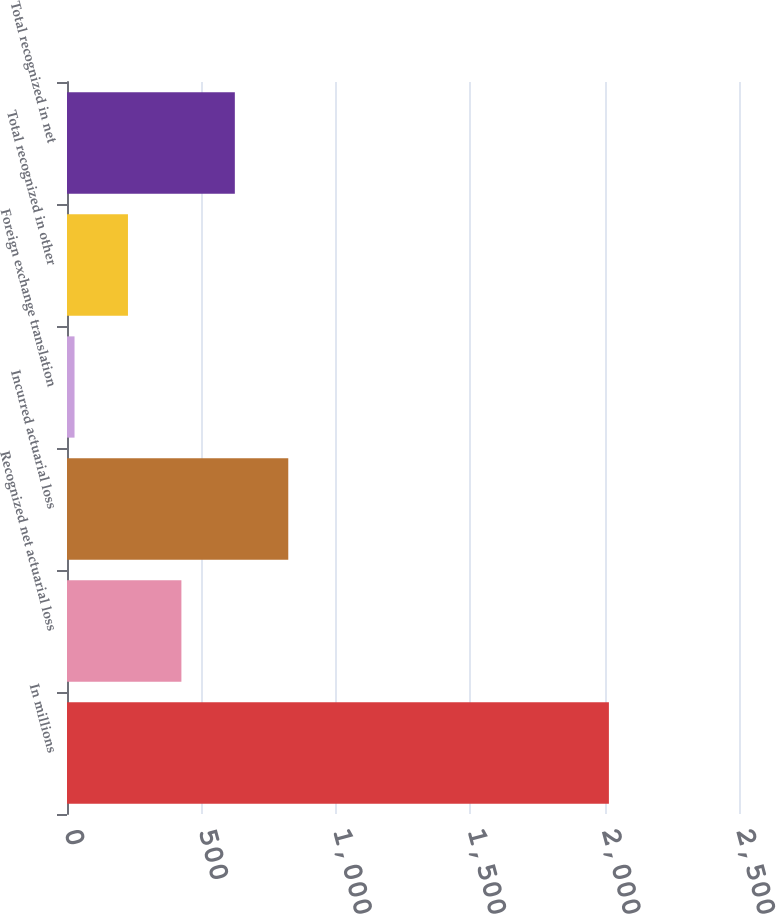Convert chart. <chart><loc_0><loc_0><loc_500><loc_500><bar_chart><fcel>In millions<fcel>Recognized net actuarial loss<fcel>Incurred actuarial loss<fcel>Foreign exchange translation<fcel>Total recognized in other<fcel>Total recognized in net<nl><fcel>2016<fcel>425.6<fcel>823.2<fcel>28<fcel>226.8<fcel>624.4<nl></chart> 